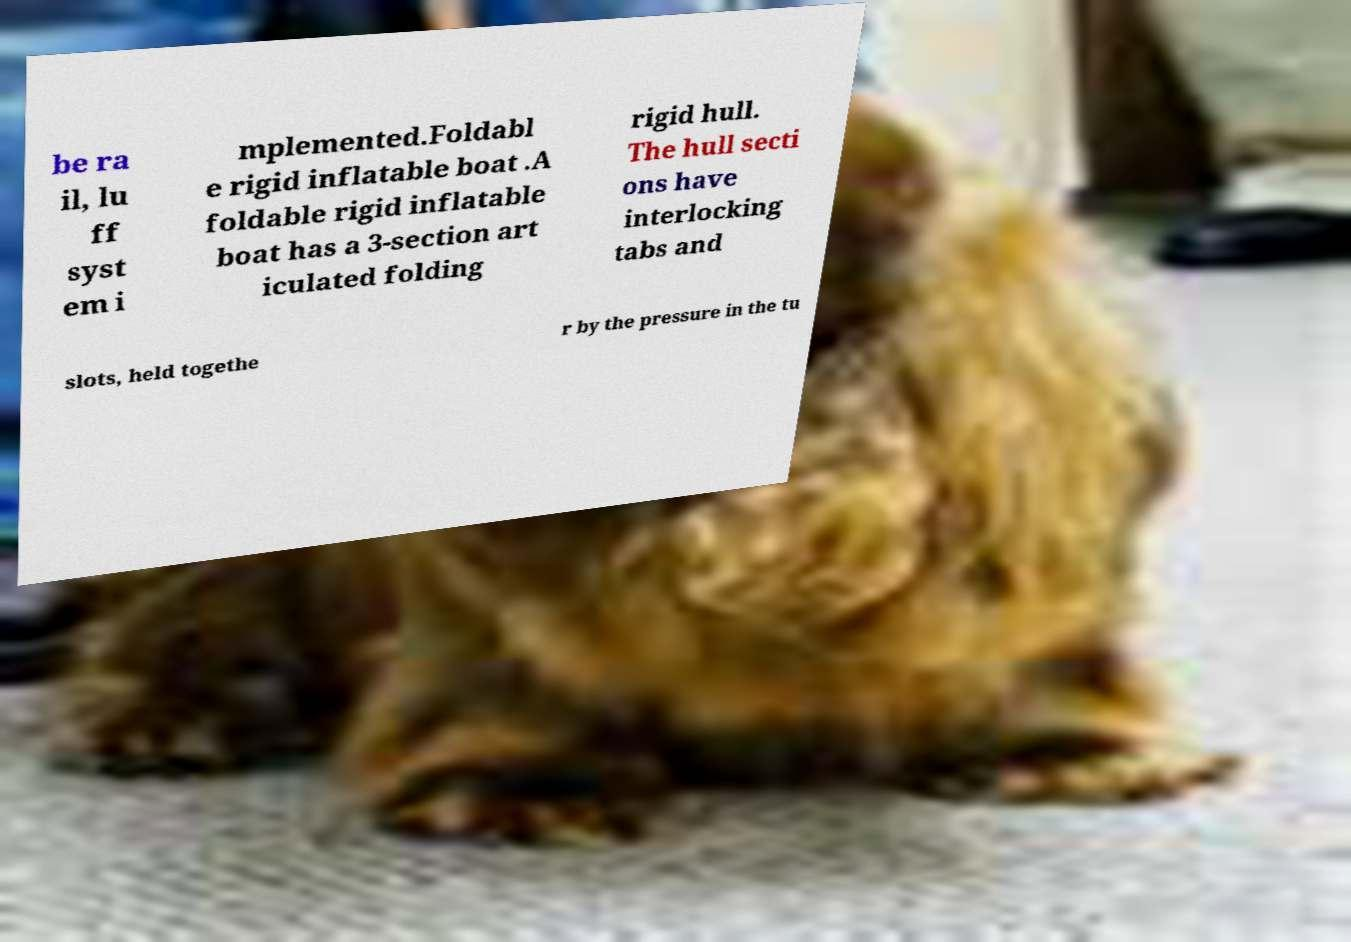Can you read and provide the text displayed in the image?This photo seems to have some interesting text. Can you extract and type it out for me? be ra il, lu ff syst em i mplemented.Foldabl e rigid inflatable boat .A foldable rigid inflatable boat has a 3-section art iculated folding rigid hull. The hull secti ons have interlocking tabs and slots, held togethe r by the pressure in the tu 